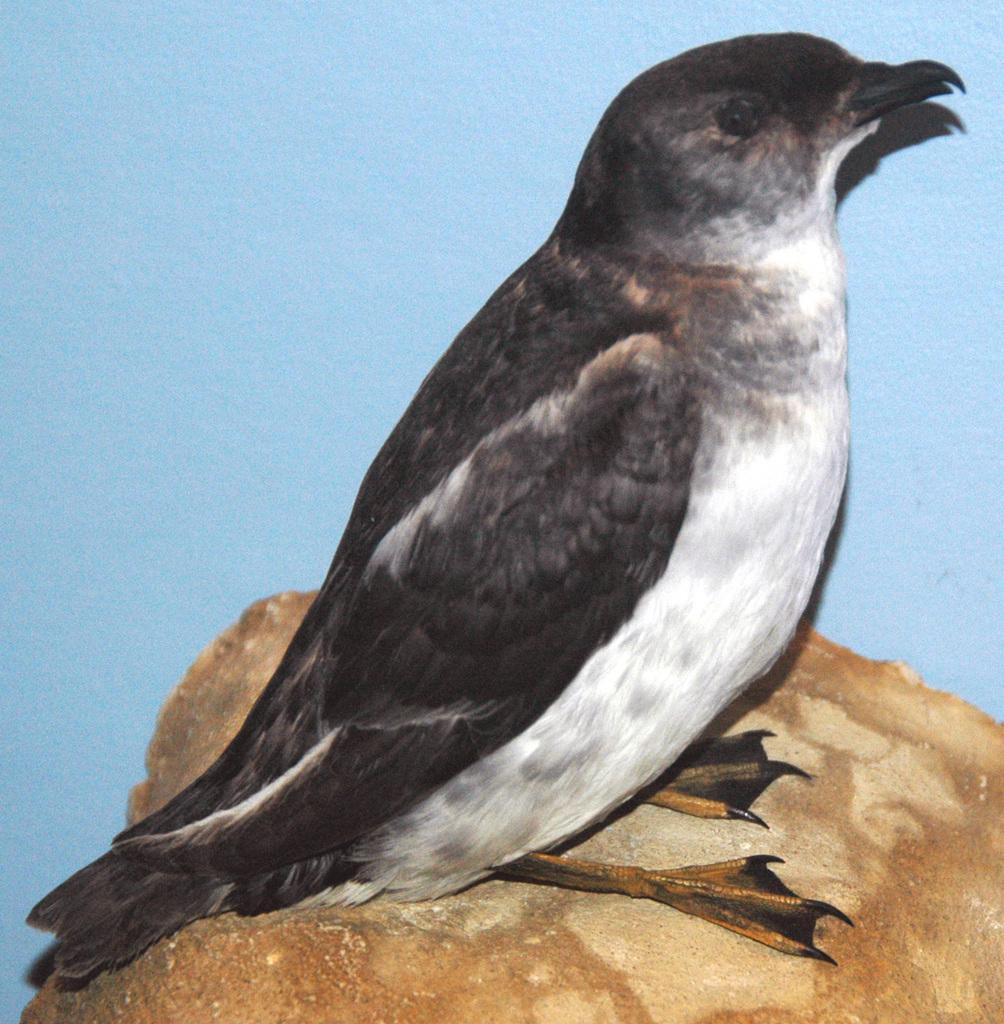In one or two sentences, can you explain what this image depicts? There is a south georgia diving petrel on a brown surface. There is a blue background. 